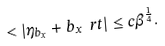<formula> <loc_0><loc_0><loc_500><loc_500>< | \eta _ { b _ { x } } + b _ { x } \ r t | \leq c \beta ^ { \frac { 1 } { 4 } } .</formula> 